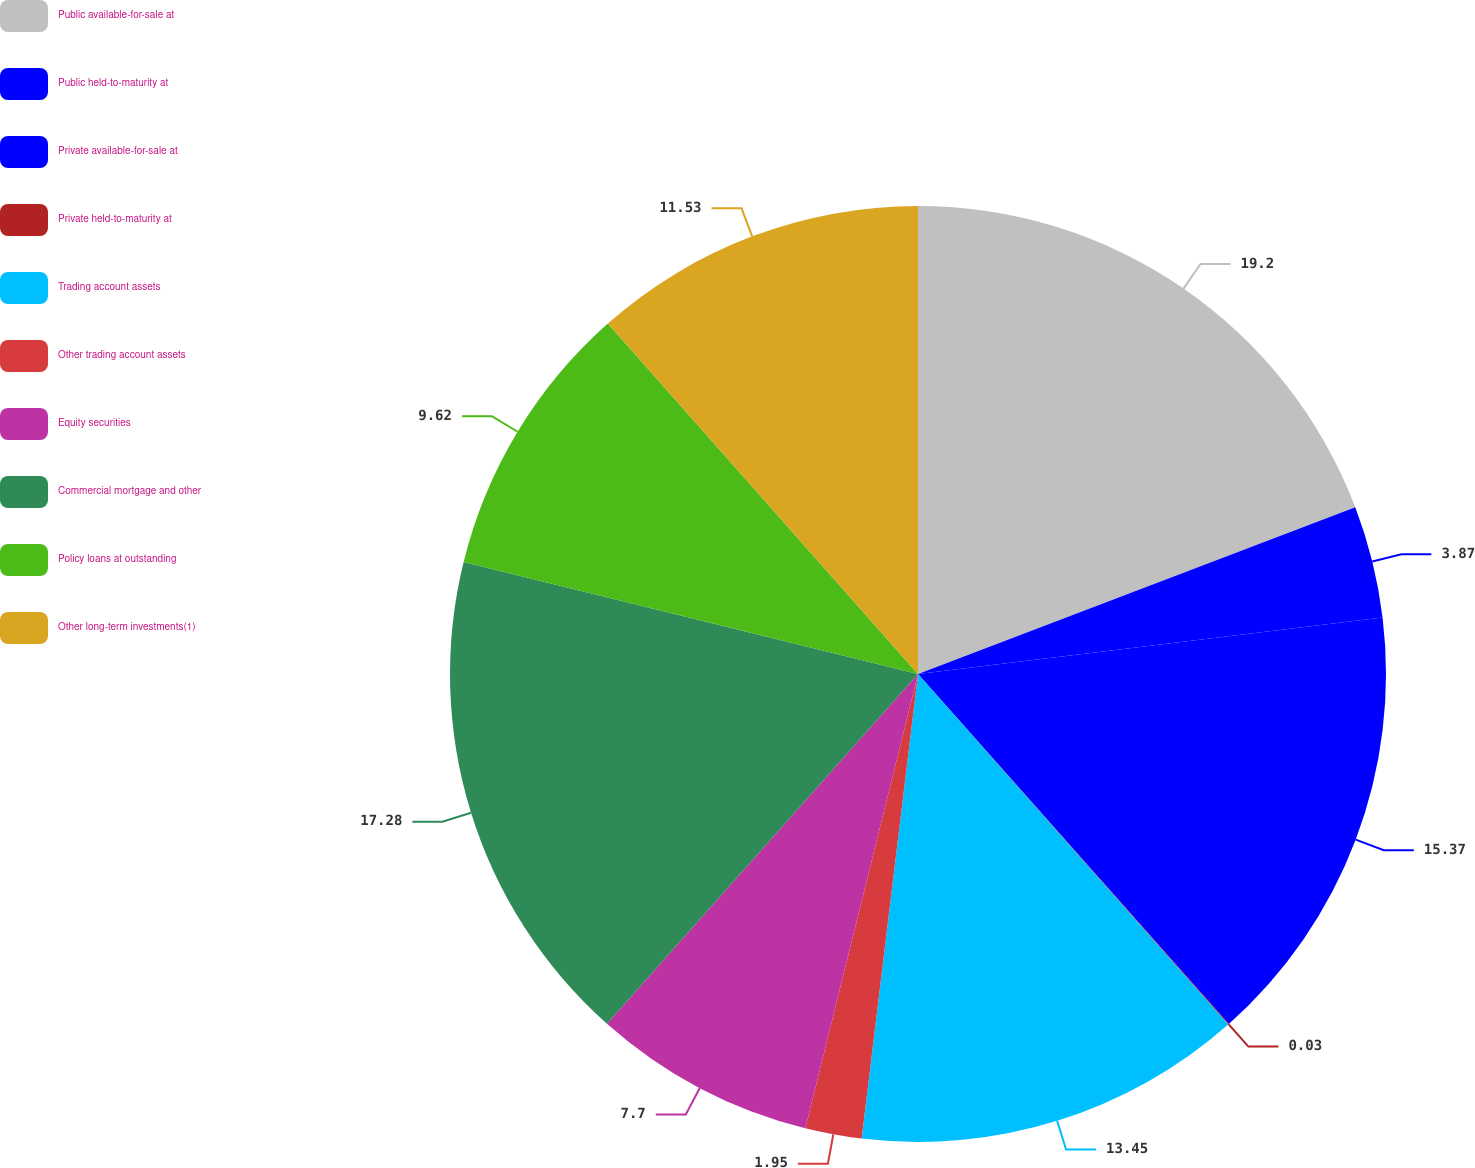Convert chart. <chart><loc_0><loc_0><loc_500><loc_500><pie_chart><fcel>Public available-for-sale at<fcel>Public held-to-maturity at<fcel>Private available-for-sale at<fcel>Private held-to-maturity at<fcel>Trading account assets<fcel>Other trading account assets<fcel>Equity securities<fcel>Commercial mortgage and other<fcel>Policy loans at outstanding<fcel>Other long-term investments(1)<nl><fcel>19.2%<fcel>3.87%<fcel>15.37%<fcel>0.03%<fcel>13.45%<fcel>1.95%<fcel>7.7%<fcel>17.28%<fcel>9.62%<fcel>11.53%<nl></chart> 